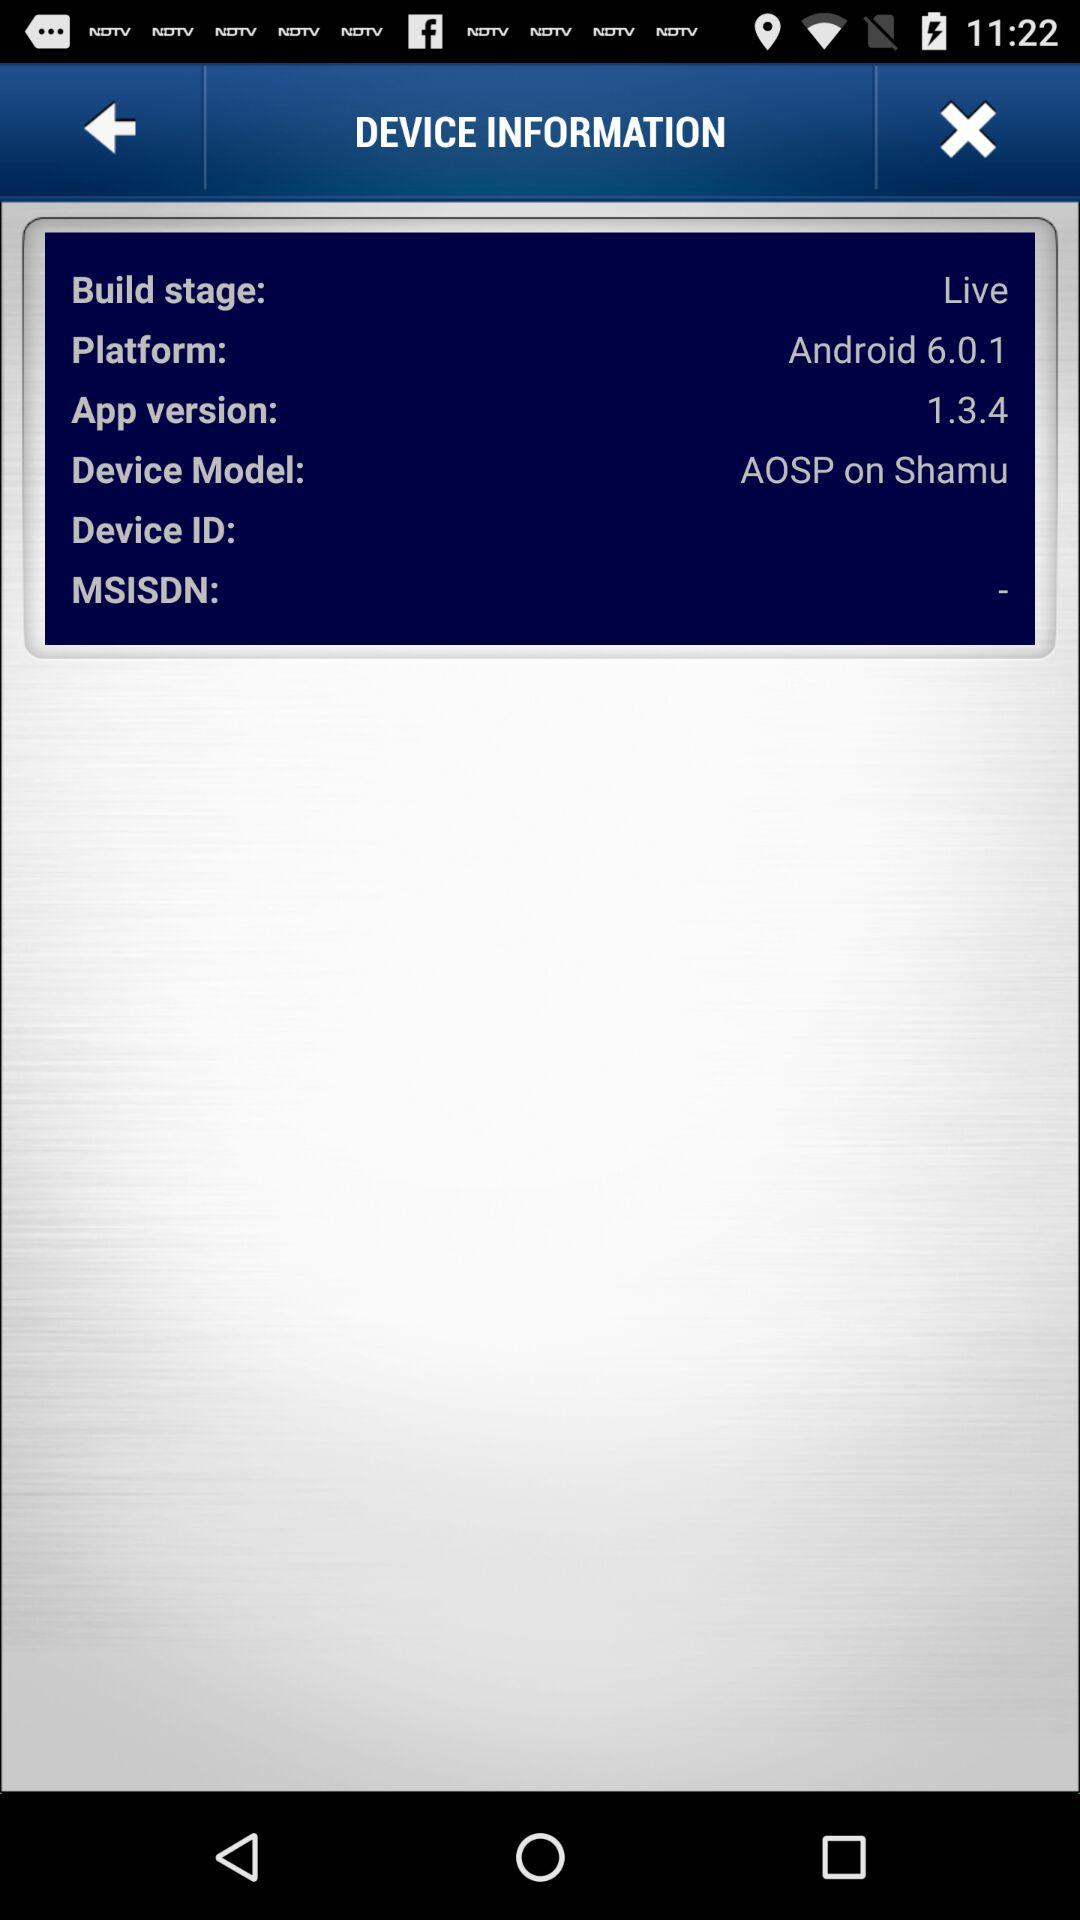What is the build stage? The build stage is live. 